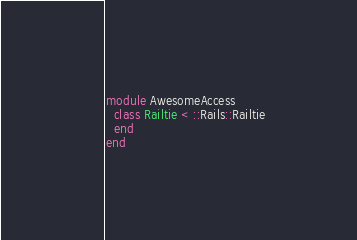Convert code to text. <code><loc_0><loc_0><loc_500><loc_500><_Ruby_>module AwesomeAccess
  class Railtie < ::Rails::Railtie
  end
end
</code> 